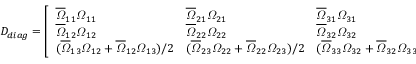Convert formula to latex. <formula><loc_0><loc_0><loc_500><loc_500>D _ { d i a g } = \left [ \begin{array} { l l l } { { \overline { \varOmega } _ { 1 1 } \varOmega _ { 1 1 } } } & { { \overline { \varOmega } _ { 2 1 } \varOmega _ { 2 1 } } } & { { \overline { \varOmega } _ { 3 1 } \varOmega _ { 3 1 } } } \\ { { \overline { \varOmega } _ { 1 2 } \varOmega _ { 1 2 } } } & { { \overline { \varOmega } _ { 2 2 } \varOmega _ { 2 2 } } } & { { \overline { \varOmega } _ { 3 2 } \varOmega _ { 3 2 } } } \\ { { ( \overline { \varOmega } _ { 1 3 } \varOmega _ { 1 2 } + \overline { \varOmega } _ { 1 2 } \varOmega _ { 1 3 } ) / 2 } } & { { ( \overline { \varOmega } _ { 2 3 } \varOmega _ { 2 2 } + \overline { \varOmega } _ { 2 2 } \varOmega _ { 2 3 } ) / 2 } } & { { ( \overline { \varOmega } _ { 3 3 } \varOmega _ { 3 2 } + \overline { \varOmega } _ { 3 2 } \varOmega _ { 3 3 } ) / 2 } } \end{array} \right ] .</formula> 